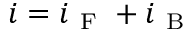<formula> <loc_0><loc_0><loc_500><loc_500>i = i _ { F } + i _ { B }</formula> 